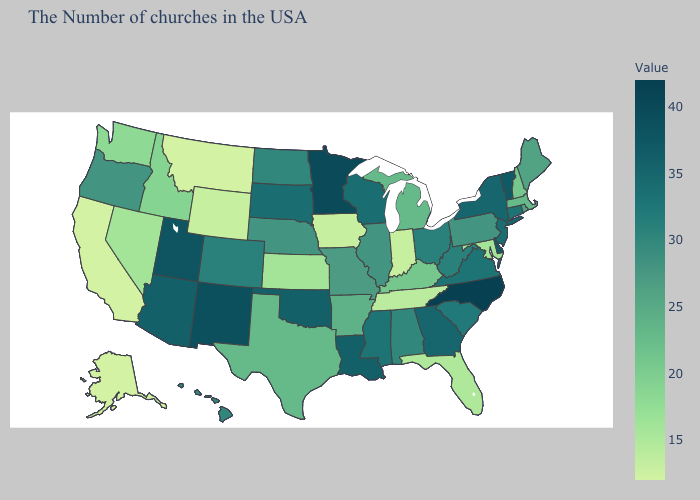Which states hav the highest value in the Northeast?
Short answer required. Vermont. Among the states that border Tennessee , which have the lowest value?
Be succinct. Kentucky. Is the legend a continuous bar?
Write a very short answer. Yes. Which states have the lowest value in the West?
Write a very short answer. Montana, California, Alaska. Does Connecticut have a higher value than Idaho?
Give a very brief answer. Yes. 